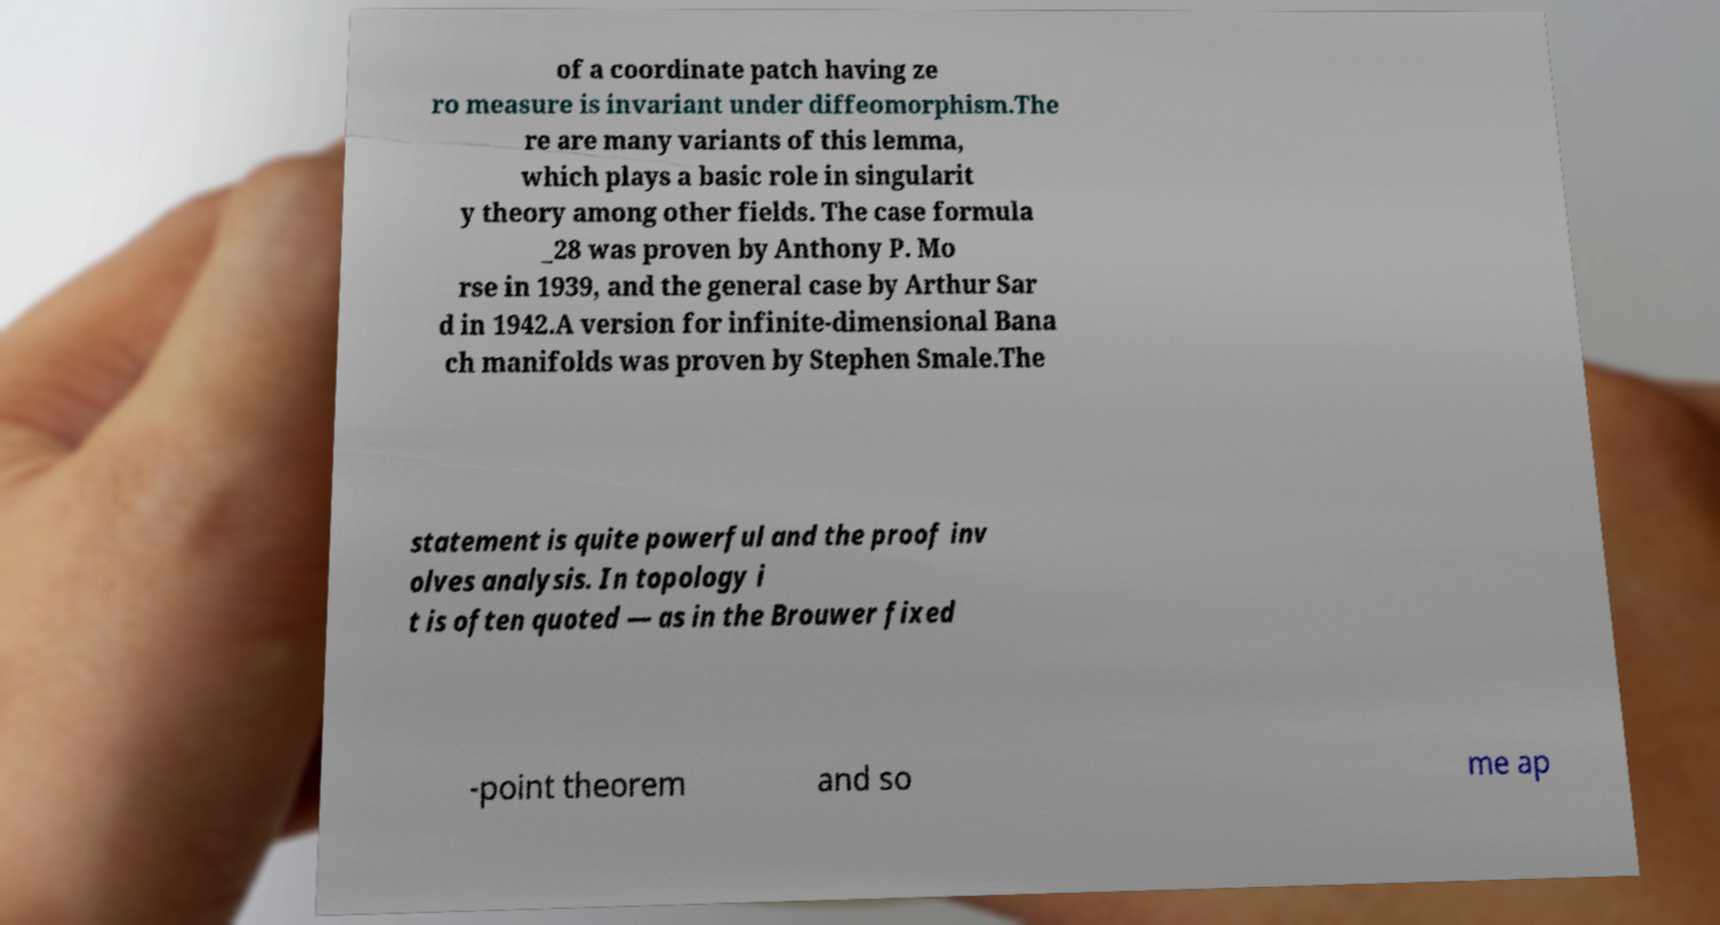Could you assist in decoding the text presented in this image and type it out clearly? of a coordinate patch having ze ro measure is invariant under diffeomorphism.The re are many variants of this lemma, which plays a basic role in singularit y theory among other fields. The case formula _28 was proven by Anthony P. Mo rse in 1939, and the general case by Arthur Sar d in 1942.A version for infinite-dimensional Bana ch manifolds was proven by Stephen Smale.The statement is quite powerful and the proof inv olves analysis. In topology i t is often quoted — as in the Brouwer fixed -point theorem and so me ap 